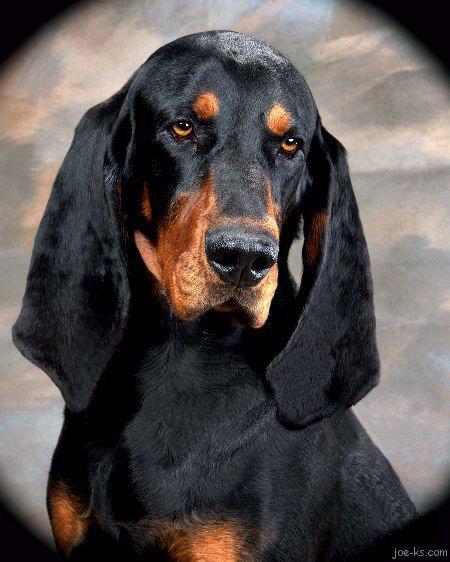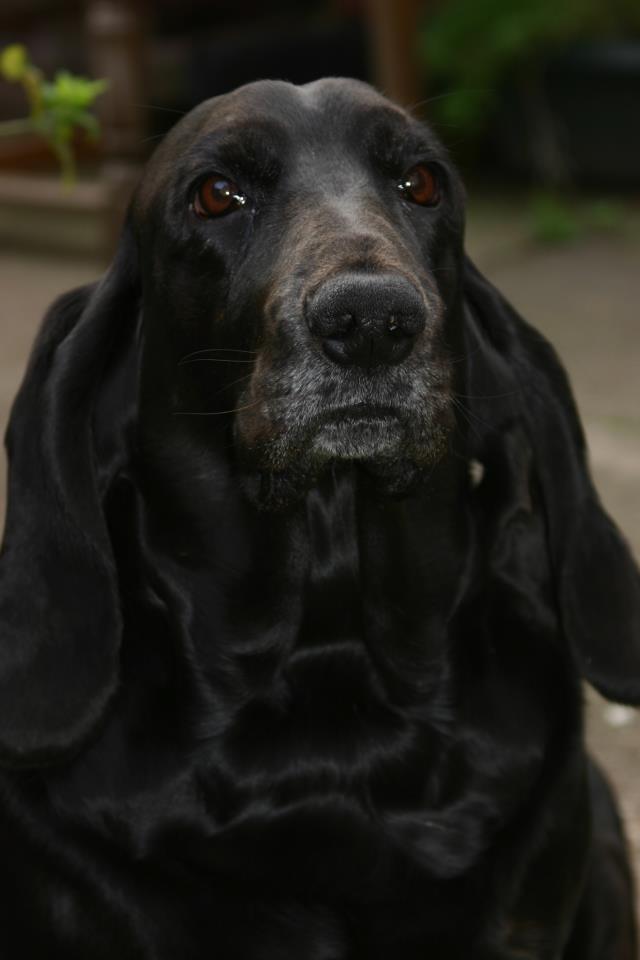The first image is the image on the left, the second image is the image on the right. Examine the images to the left and right. Is the description "One of the dogs is sitting on or lying next to a pillow." accurate? Answer yes or no. No. 